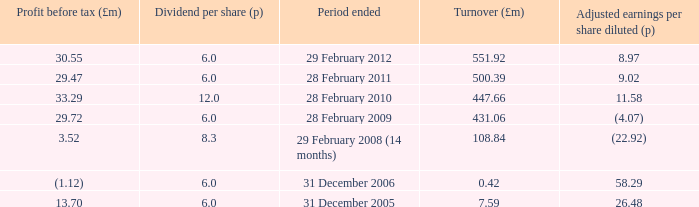How many items appear in the dividend per share when the turnover is 0.42? 1.0. 